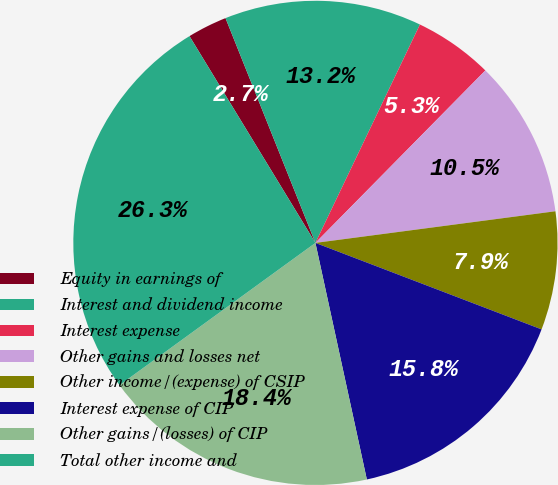Convert chart. <chart><loc_0><loc_0><loc_500><loc_500><pie_chart><fcel>Equity in earnings of<fcel>Interest and dividend income<fcel>Interest expense<fcel>Other gains and losses net<fcel>Other income/(expense) of CSIP<fcel>Interest expense of CIP<fcel>Other gains/(losses) of CIP<fcel>Total other income and<nl><fcel>2.65%<fcel>13.16%<fcel>5.28%<fcel>10.53%<fcel>7.9%<fcel>15.78%<fcel>18.41%<fcel>26.29%<nl></chart> 